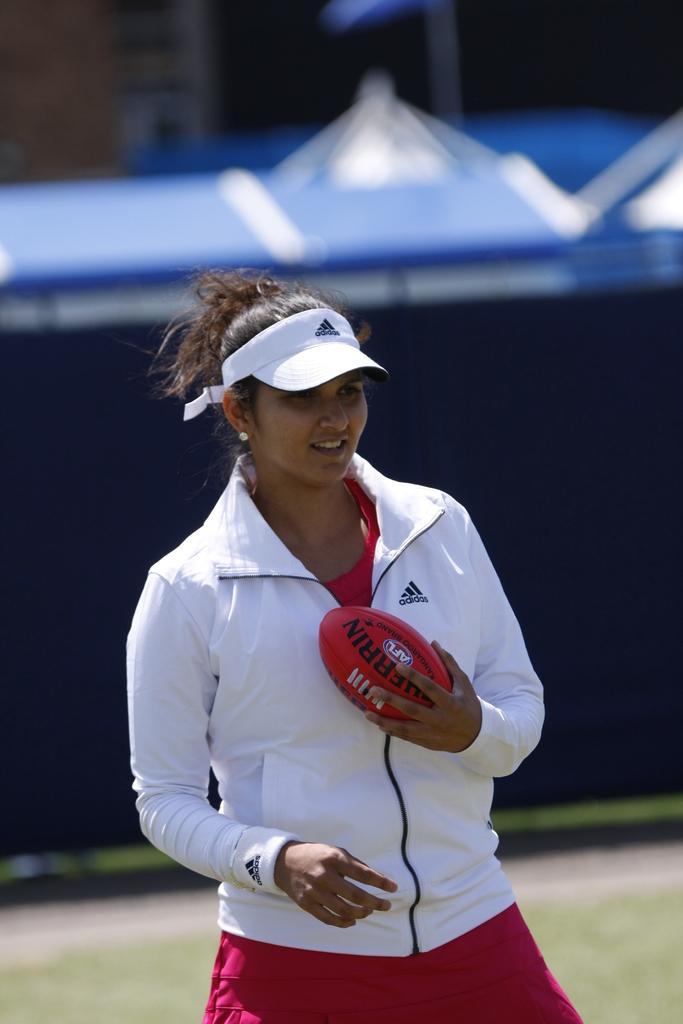Please provide a concise description of this image. In this picture there is a woman who is wearing a white jacket and carrying a rugby ball in her hand. She is wearing a white cap on her head. 